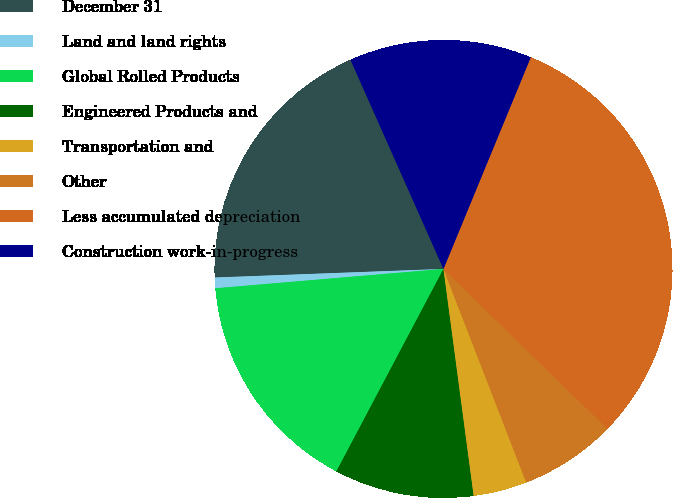Convert chart. <chart><loc_0><loc_0><loc_500><loc_500><pie_chart><fcel>December 31<fcel>Land and land rights<fcel>Global Rolled Products<fcel>Engineered Products and<fcel>Transportation and<fcel>Other<fcel>Less accumulated depreciation<fcel>Construction work-in-progress<nl><fcel>18.94%<fcel>0.75%<fcel>15.91%<fcel>9.85%<fcel>3.78%<fcel>6.82%<fcel>31.07%<fcel>12.88%<nl></chart> 